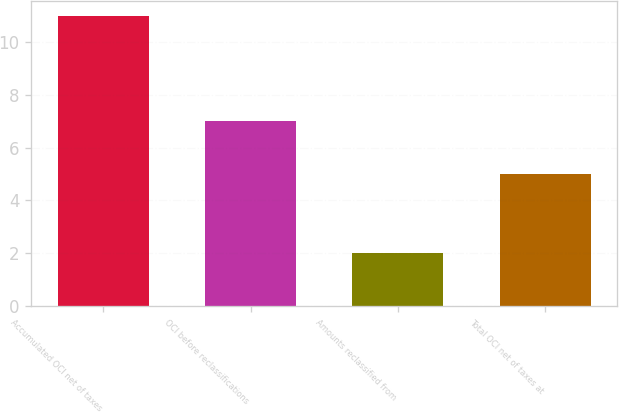Convert chart. <chart><loc_0><loc_0><loc_500><loc_500><bar_chart><fcel>Accumulated OCI net of taxes<fcel>OCI before reclassifications<fcel>Amounts reclassified from<fcel>Total OCI net of taxes at<nl><fcel>11<fcel>7<fcel>2<fcel>5<nl></chart> 